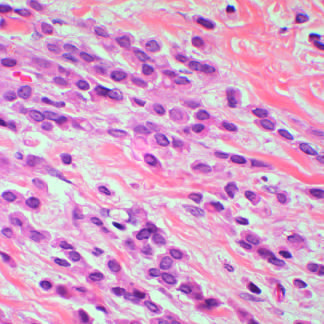what are composed of noncohesive tumor cells that invade as linear cords of cells and induce little stromal response?
Answer the question using a single word or phrase. Lobular carcinomas 